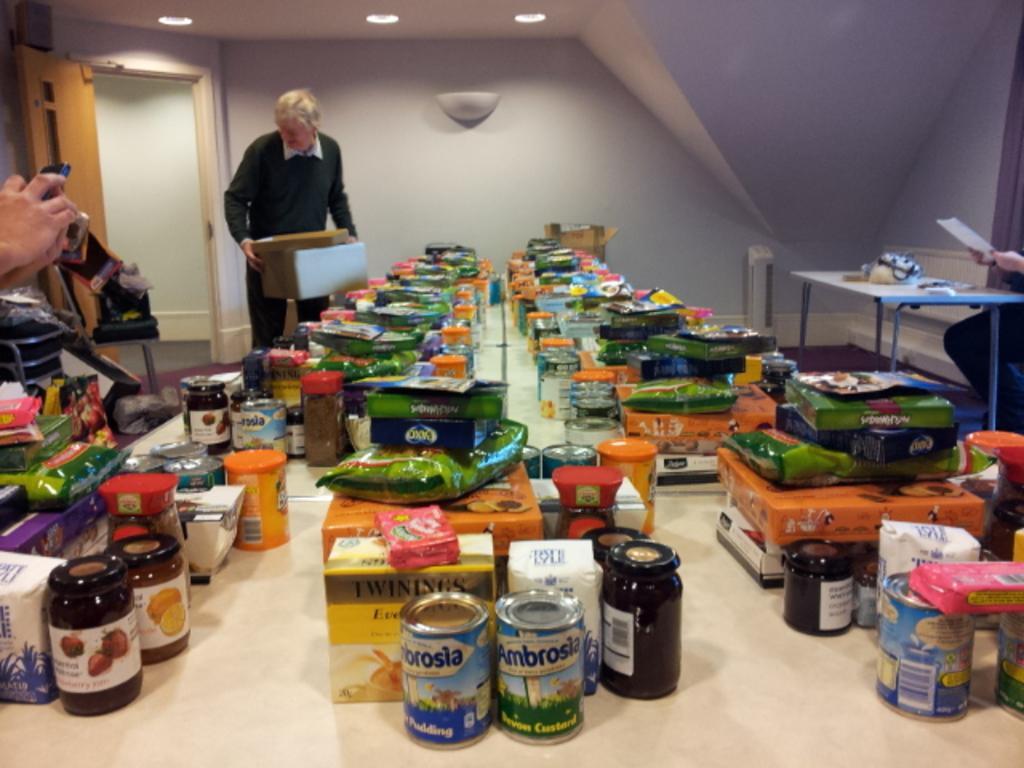Describe this image in one or two sentences. To the front bottom of the image there is a table with packets, tins, jars and few other items on it. To the right side of the image there is a table with a few items on it. And behind the table there is a person sitting. And in the background there is a man with black jacket is standing and holding a cardboard box in his hands. Behind him there is a white wall. To the left side of the of the image there is a door. And to the top of the image there are lights. 